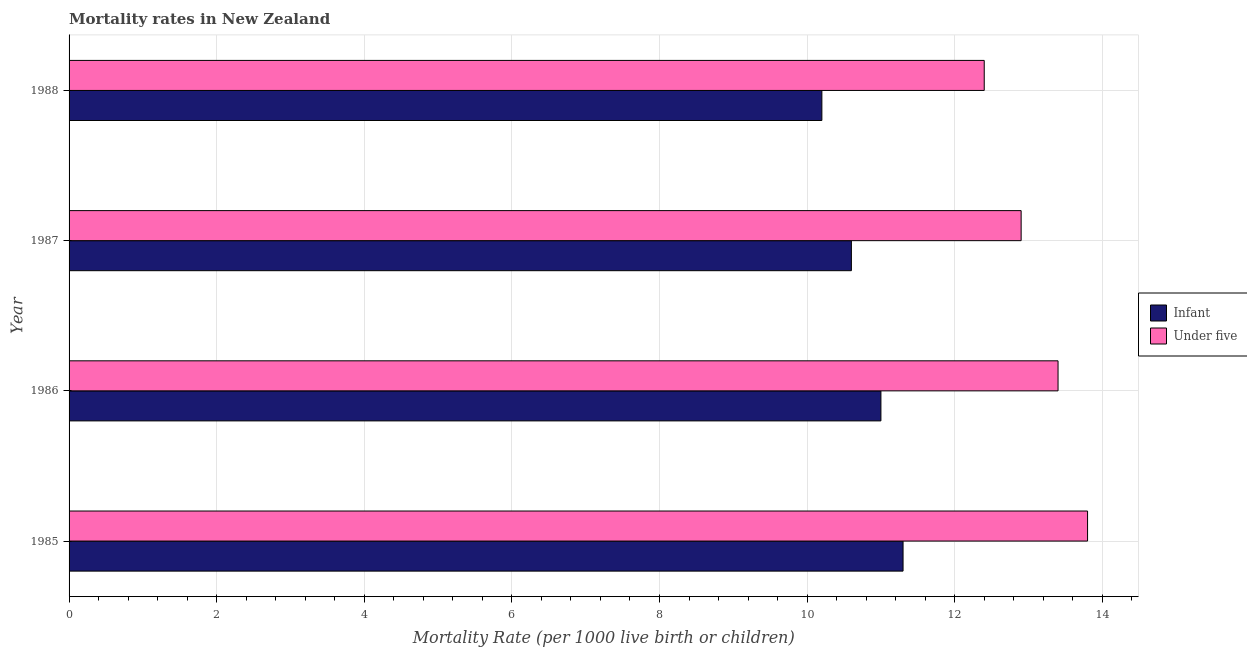Are the number of bars per tick equal to the number of legend labels?
Offer a very short reply. Yes. Are the number of bars on each tick of the Y-axis equal?
Keep it short and to the point. Yes. What is the infant mortality rate in 1988?
Provide a short and direct response. 10.2. Across all years, what is the maximum infant mortality rate?
Give a very brief answer. 11.3. Across all years, what is the minimum infant mortality rate?
Your response must be concise. 10.2. In which year was the infant mortality rate maximum?
Offer a terse response. 1985. What is the total under-5 mortality rate in the graph?
Keep it short and to the point. 52.5. What is the difference between the infant mortality rate in 1987 and that in 1988?
Make the answer very short. 0.4. What is the difference between the under-5 mortality rate in 1985 and the infant mortality rate in 1987?
Offer a terse response. 3.2. What is the average under-5 mortality rate per year?
Offer a very short reply. 13.12. In the year 1986, what is the difference between the infant mortality rate and under-5 mortality rate?
Your answer should be very brief. -2.4. What is the ratio of the infant mortality rate in 1985 to that in 1987?
Provide a succinct answer. 1.07. Is the difference between the infant mortality rate in 1985 and 1986 greater than the difference between the under-5 mortality rate in 1985 and 1986?
Ensure brevity in your answer.  No. What is the difference between the highest and the lowest infant mortality rate?
Your response must be concise. 1.1. In how many years, is the infant mortality rate greater than the average infant mortality rate taken over all years?
Offer a very short reply. 2. Is the sum of the under-5 mortality rate in 1986 and 1987 greater than the maximum infant mortality rate across all years?
Offer a terse response. Yes. What does the 2nd bar from the top in 1985 represents?
Provide a succinct answer. Infant. What does the 2nd bar from the bottom in 1988 represents?
Keep it short and to the point. Under five. What is the difference between two consecutive major ticks on the X-axis?
Your answer should be compact. 2. Are the values on the major ticks of X-axis written in scientific E-notation?
Offer a very short reply. No. Does the graph contain grids?
Make the answer very short. Yes. How many legend labels are there?
Your response must be concise. 2. How are the legend labels stacked?
Provide a succinct answer. Vertical. What is the title of the graph?
Your answer should be very brief. Mortality rates in New Zealand. Does "Mineral" appear as one of the legend labels in the graph?
Give a very brief answer. No. What is the label or title of the X-axis?
Ensure brevity in your answer.  Mortality Rate (per 1000 live birth or children). What is the label or title of the Y-axis?
Offer a terse response. Year. What is the Mortality Rate (per 1000 live birth or children) in Infant in 1986?
Provide a short and direct response. 11. What is the Mortality Rate (per 1000 live birth or children) of Infant in 1987?
Give a very brief answer. 10.6. What is the Mortality Rate (per 1000 live birth or children) in Under five in 1987?
Provide a short and direct response. 12.9. What is the Mortality Rate (per 1000 live birth or children) in Under five in 1988?
Offer a terse response. 12.4. Across all years, what is the maximum Mortality Rate (per 1000 live birth or children) in Infant?
Provide a succinct answer. 11.3. Across all years, what is the minimum Mortality Rate (per 1000 live birth or children) of Infant?
Your answer should be very brief. 10.2. Across all years, what is the minimum Mortality Rate (per 1000 live birth or children) in Under five?
Keep it short and to the point. 12.4. What is the total Mortality Rate (per 1000 live birth or children) in Infant in the graph?
Provide a succinct answer. 43.1. What is the total Mortality Rate (per 1000 live birth or children) in Under five in the graph?
Provide a short and direct response. 52.5. What is the difference between the Mortality Rate (per 1000 live birth or children) in Infant in 1985 and that in 1986?
Give a very brief answer. 0.3. What is the difference between the Mortality Rate (per 1000 live birth or children) of Under five in 1985 and that in 1986?
Keep it short and to the point. 0.4. What is the difference between the Mortality Rate (per 1000 live birth or children) of Under five in 1986 and that in 1987?
Offer a terse response. 0.5. What is the difference between the Mortality Rate (per 1000 live birth or children) of Infant in 1986 and that in 1988?
Make the answer very short. 0.8. What is the difference between the Mortality Rate (per 1000 live birth or children) of Under five in 1986 and that in 1988?
Ensure brevity in your answer.  1. What is the difference between the Mortality Rate (per 1000 live birth or children) in Infant in 1987 and that in 1988?
Your response must be concise. 0.4. What is the difference between the Mortality Rate (per 1000 live birth or children) of Infant in 1985 and the Mortality Rate (per 1000 live birth or children) of Under five in 1987?
Offer a very short reply. -1.6. What is the difference between the Mortality Rate (per 1000 live birth or children) of Infant in 1985 and the Mortality Rate (per 1000 live birth or children) of Under five in 1988?
Keep it short and to the point. -1.1. What is the difference between the Mortality Rate (per 1000 live birth or children) of Infant in 1986 and the Mortality Rate (per 1000 live birth or children) of Under five in 1987?
Your response must be concise. -1.9. What is the average Mortality Rate (per 1000 live birth or children) of Infant per year?
Ensure brevity in your answer.  10.78. What is the average Mortality Rate (per 1000 live birth or children) in Under five per year?
Provide a short and direct response. 13.12. In the year 1988, what is the difference between the Mortality Rate (per 1000 live birth or children) in Infant and Mortality Rate (per 1000 live birth or children) in Under five?
Your response must be concise. -2.2. What is the ratio of the Mortality Rate (per 1000 live birth or children) of Infant in 1985 to that in 1986?
Make the answer very short. 1.03. What is the ratio of the Mortality Rate (per 1000 live birth or children) of Under five in 1985 to that in 1986?
Ensure brevity in your answer.  1.03. What is the ratio of the Mortality Rate (per 1000 live birth or children) of Infant in 1985 to that in 1987?
Offer a terse response. 1.07. What is the ratio of the Mortality Rate (per 1000 live birth or children) in Under five in 1985 to that in 1987?
Offer a very short reply. 1.07. What is the ratio of the Mortality Rate (per 1000 live birth or children) in Infant in 1985 to that in 1988?
Make the answer very short. 1.11. What is the ratio of the Mortality Rate (per 1000 live birth or children) in Under five in 1985 to that in 1988?
Your answer should be compact. 1.11. What is the ratio of the Mortality Rate (per 1000 live birth or children) of Infant in 1986 to that in 1987?
Offer a very short reply. 1.04. What is the ratio of the Mortality Rate (per 1000 live birth or children) in Under five in 1986 to that in 1987?
Make the answer very short. 1.04. What is the ratio of the Mortality Rate (per 1000 live birth or children) in Infant in 1986 to that in 1988?
Keep it short and to the point. 1.08. What is the ratio of the Mortality Rate (per 1000 live birth or children) in Under five in 1986 to that in 1988?
Provide a short and direct response. 1.08. What is the ratio of the Mortality Rate (per 1000 live birth or children) in Infant in 1987 to that in 1988?
Ensure brevity in your answer.  1.04. What is the ratio of the Mortality Rate (per 1000 live birth or children) of Under five in 1987 to that in 1988?
Your response must be concise. 1.04. What is the difference between the highest and the second highest Mortality Rate (per 1000 live birth or children) of Infant?
Provide a short and direct response. 0.3. What is the difference between the highest and the second highest Mortality Rate (per 1000 live birth or children) in Under five?
Give a very brief answer. 0.4. What is the difference between the highest and the lowest Mortality Rate (per 1000 live birth or children) of Infant?
Your response must be concise. 1.1. What is the difference between the highest and the lowest Mortality Rate (per 1000 live birth or children) in Under five?
Ensure brevity in your answer.  1.4. 